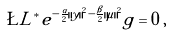Convert formula to latex. <formula><loc_0><loc_0><loc_500><loc_500>\L L ^ { * } e ^ { - \frac { \alpha } { 2 } \| y \| ^ { 2 } - \frac { \beta } { 2 } \| \mu \| ^ { 2 } } g = 0 \, ,</formula> 